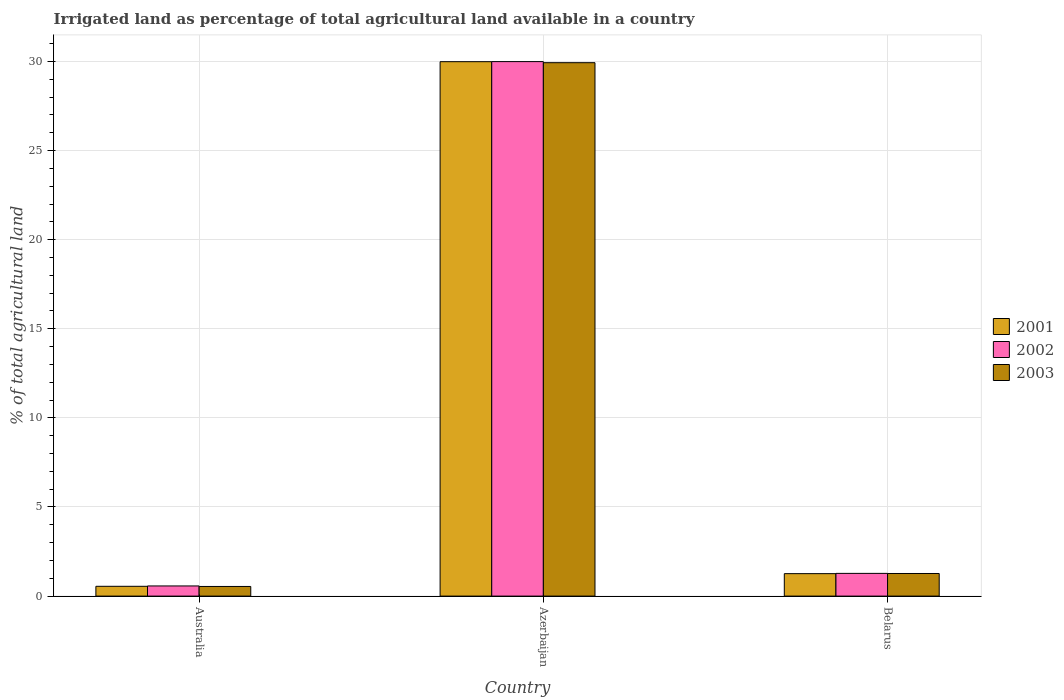How many groups of bars are there?
Offer a very short reply. 3. Are the number of bars on each tick of the X-axis equal?
Your answer should be compact. Yes. How many bars are there on the 3rd tick from the right?
Your answer should be compact. 3. What is the label of the 1st group of bars from the left?
Your answer should be compact. Australia. What is the percentage of irrigated land in 2001 in Azerbaijan?
Make the answer very short. 29.99. Across all countries, what is the maximum percentage of irrigated land in 2002?
Keep it short and to the point. 29.99. Across all countries, what is the minimum percentage of irrigated land in 2002?
Give a very brief answer. 0.57. In which country was the percentage of irrigated land in 2003 maximum?
Your answer should be very brief. Azerbaijan. In which country was the percentage of irrigated land in 2002 minimum?
Your response must be concise. Australia. What is the total percentage of irrigated land in 2002 in the graph?
Provide a succinct answer. 31.83. What is the difference between the percentage of irrigated land in 2003 in Australia and that in Azerbaijan?
Your response must be concise. -29.39. What is the difference between the percentage of irrigated land in 2003 in Belarus and the percentage of irrigated land in 2001 in Azerbaijan?
Provide a short and direct response. -28.72. What is the average percentage of irrigated land in 2001 per country?
Your answer should be very brief. 10.6. What is the difference between the percentage of irrigated land of/in 2002 and percentage of irrigated land of/in 2003 in Australia?
Your answer should be very brief. 0.03. What is the ratio of the percentage of irrigated land in 2003 in Australia to that in Belarus?
Offer a very short reply. 0.43. Is the percentage of irrigated land in 2002 in Australia less than that in Belarus?
Ensure brevity in your answer.  Yes. Is the difference between the percentage of irrigated land in 2002 in Azerbaijan and Belarus greater than the difference between the percentage of irrigated land in 2003 in Azerbaijan and Belarus?
Offer a terse response. Yes. What is the difference between the highest and the second highest percentage of irrigated land in 2002?
Provide a short and direct response. -0.7. What is the difference between the highest and the lowest percentage of irrigated land in 2003?
Ensure brevity in your answer.  29.39. In how many countries, is the percentage of irrigated land in 2003 greater than the average percentage of irrigated land in 2003 taken over all countries?
Your answer should be very brief. 1. Is the sum of the percentage of irrigated land in 2002 in Australia and Azerbaijan greater than the maximum percentage of irrigated land in 2001 across all countries?
Your answer should be compact. Yes. What does the 1st bar from the right in Azerbaijan represents?
Your answer should be very brief. 2003. Are all the bars in the graph horizontal?
Ensure brevity in your answer.  No. How many countries are there in the graph?
Give a very brief answer. 3. Are the values on the major ticks of Y-axis written in scientific E-notation?
Provide a succinct answer. No. Does the graph contain any zero values?
Give a very brief answer. No. Does the graph contain grids?
Provide a short and direct response. Yes. Where does the legend appear in the graph?
Ensure brevity in your answer.  Center right. How many legend labels are there?
Give a very brief answer. 3. How are the legend labels stacked?
Provide a succinct answer. Vertical. What is the title of the graph?
Keep it short and to the point. Irrigated land as percentage of total agricultural land available in a country. What is the label or title of the X-axis?
Make the answer very short. Country. What is the label or title of the Y-axis?
Your answer should be compact. % of total agricultural land. What is the % of total agricultural land of 2001 in Australia?
Offer a very short reply. 0.55. What is the % of total agricultural land of 2002 in Australia?
Offer a very short reply. 0.57. What is the % of total agricultural land of 2003 in Australia?
Ensure brevity in your answer.  0.54. What is the % of total agricultural land in 2001 in Azerbaijan?
Provide a short and direct response. 29.99. What is the % of total agricultural land in 2002 in Azerbaijan?
Offer a terse response. 29.99. What is the % of total agricultural land in 2003 in Azerbaijan?
Provide a short and direct response. 29.93. What is the % of total agricultural land in 2001 in Belarus?
Ensure brevity in your answer.  1.26. What is the % of total agricultural land in 2002 in Belarus?
Make the answer very short. 1.27. What is the % of total agricultural land in 2003 in Belarus?
Offer a terse response. 1.27. Across all countries, what is the maximum % of total agricultural land of 2001?
Offer a very short reply. 29.99. Across all countries, what is the maximum % of total agricultural land of 2002?
Offer a terse response. 29.99. Across all countries, what is the maximum % of total agricultural land in 2003?
Your response must be concise. 29.93. Across all countries, what is the minimum % of total agricultural land in 2001?
Offer a very short reply. 0.55. Across all countries, what is the minimum % of total agricultural land of 2002?
Your response must be concise. 0.57. Across all countries, what is the minimum % of total agricultural land in 2003?
Your response must be concise. 0.54. What is the total % of total agricultural land in 2001 in the graph?
Offer a terse response. 31.8. What is the total % of total agricultural land of 2002 in the graph?
Provide a succinct answer. 31.83. What is the total % of total agricultural land of 2003 in the graph?
Keep it short and to the point. 31.74. What is the difference between the % of total agricultural land in 2001 in Australia and that in Azerbaijan?
Give a very brief answer. -29.44. What is the difference between the % of total agricultural land in 2002 in Australia and that in Azerbaijan?
Your response must be concise. -29.42. What is the difference between the % of total agricultural land in 2003 in Australia and that in Azerbaijan?
Your response must be concise. -29.39. What is the difference between the % of total agricultural land of 2001 in Australia and that in Belarus?
Your answer should be compact. -0.71. What is the difference between the % of total agricultural land in 2002 in Australia and that in Belarus?
Your response must be concise. -0.7. What is the difference between the % of total agricultural land of 2003 in Australia and that in Belarus?
Offer a very short reply. -0.73. What is the difference between the % of total agricultural land in 2001 in Azerbaijan and that in Belarus?
Keep it short and to the point. 28.73. What is the difference between the % of total agricultural land in 2002 in Azerbaijan and that in Belarus?
Make the answer very short. 28.72. What is the difference between the % of total agricultural land in 2003 in Azerbaijan and that in Belarus?
Provide a succinct answer. 28.66. What is the difference between the % of total agricultural land in 2001 in Australia and the % of total agricultural land in 2002 in Azerbaijan?
Offer a very short reply. -29.44. What is the difference between the % of total agricultural land of 2001 in Australia and the % of total agricultural land of 2003 in Azerbaijan?
Offer a very short reply. -29.38. What is the difference between the % of total agricultural land in 2002 in Australia and the % of total agricultural land in 2003 in Azerbaijan?
Provide a short and direct response. -29.36. What is the difference between the % of total agricultural land in 2001 in Australia and the % of total agricultural land in 2002 in Belarus?
Provide a succinct answer. -0.72. What is the difference between the % of total agricultural land in 2001 in Australia and the % of total agricultural land in 2003 in Belarus?
Give a very brief answer. -0.72. What is the difference between the % of total agricultural land in 2002 in Australia and the % of total agricultural land in 2003 in Belarus?
Keep it short and to the point. -0.7. What is the difference between the % of total agricultural land in 2001 in Azerbaijan and the % of total agricultural land in 2002 in Belarus?
Offer a terse response. 28.71. What is the difference between the % of total agricultural land in 2001 in Azerbaijan and the % of total agricultural land in 2003 in Belarus?
Give a very brief answer. 28.72. What is the difference between the % of total agricultural land of 2002 in Azerbaijan and the % of total agricultural land of 2003 in Belarus?
Offer a very short reply. 28.72. What is the average % of total agricultural land in 2001 per country?
Keep it short and to the point. 10.6. What is the average % of total agricultural land of 2002 per country?
Give a very brief answer. 10.61. What is the average % of total agricultural land in 2003 per country?
Your answer should be compact. 10.58. What is the difference between the % of total agricultural land of 2001 and % of total agricultural land of 2002 in Australia?
Offer a very short reply. -0.02. What is the difference between the % of total agricultural land in 2001 and % of total agricultural land in 2003 in Australia?
Provide a short and direct response. 0.01. What is the difference between the % of total agricultural land of 2002 and % of total agricultural land of 2003 in Australia?
Provide a succinct answer. 0.03. What is the difference between the % of total agricultural land of 2001 and % of total agricultural land of 2002 in Azerbaijan?
Ensure brevity in your answer.  -0. What is the difference between the % of total agricultural land of 2001 and % of total agricultural land of 2003 in Azerbaijan?
Your response must be concise. 0.06. What is the difference between the % of total agricultural land in 2002 and % of total agricultural land in 2003 in Azerbaijan?
Your response must be concise. 0.06. What is the difference between the % of total agricultural land of 2001 and % of total agricultural land of 2002 in Belarus?
Your answer should be very brief. -0.01. What is the difference between the % of total agricultural land of 2001 and % of total agricultural land of 2003 in Belarus?
Your answer should be very brief. -0.01. What is the difference between the % of total agricultural land in 2002 and % of total agricultural land in 2003 in Belarus?
Offer a very short reply. 0.01. What is the ratio of the % of total agricultural land of 2001 in Australia to that in Azerbaijan?
Offer a terse response. 0.02. What is the ratio of the % of total agricultural land in 2002 in Australia to that in Azerbaijan?
Keep it short and to the point. 0.02. What is the ratio of the % of total agricultural land in 2003 in Australia to that in Azerbaijan?
Provide a short and direct response. 0.02. What is the ratio of the % of total agricultural land in 2001 in Australia to that in Belarus?
Offer a very short reply. 0.44. What is the ratio of the % of total agricultural land in 2002 in Australia to that in Belarus?
Ensure brevity in your answer.  0.45. What is the ratio of the % of total agricultural land of 2003 in Australia to that in Belarus?
Offer a very short reply. 0.43. What is the ratio of the % of total agricultural land in 2001 in Azerbaijan to that in Belarus?
Make the answer very short. 23.8. What is the ratio of the % of total agricultural land in 2002 in Azerbaijan to that in Belarus?
Provide a succinct answer. 23.54. What is the ratio of the % of total agricultural land in 2003 in Azerbaijan to that in Belarus?
Offer a terse response. 23.59. What is the difference between the highest and the second highest % of total agricultural land in 2001?
Give a very brief answer. 28.73. What is the difference between the highest and the second highest % of total agricultural land of 2002?
Your answer should be very brief. 28.72. What is the difference between the highest and the second highest % of total agricultural land of 2003?
Your answer should be very brief. 28.66. What is the difference between the highest and the lowest % of total agricultural land in 2001?
Give a very brief answer. 29.44. What is the difference between the highest and the lowest % of total agricultural land in 2002?
Give a very brief answer. 29.42. What is the difference between the highest and the lowest % of total agricultural land of 2003?
Offer a terse response. 29.39. 